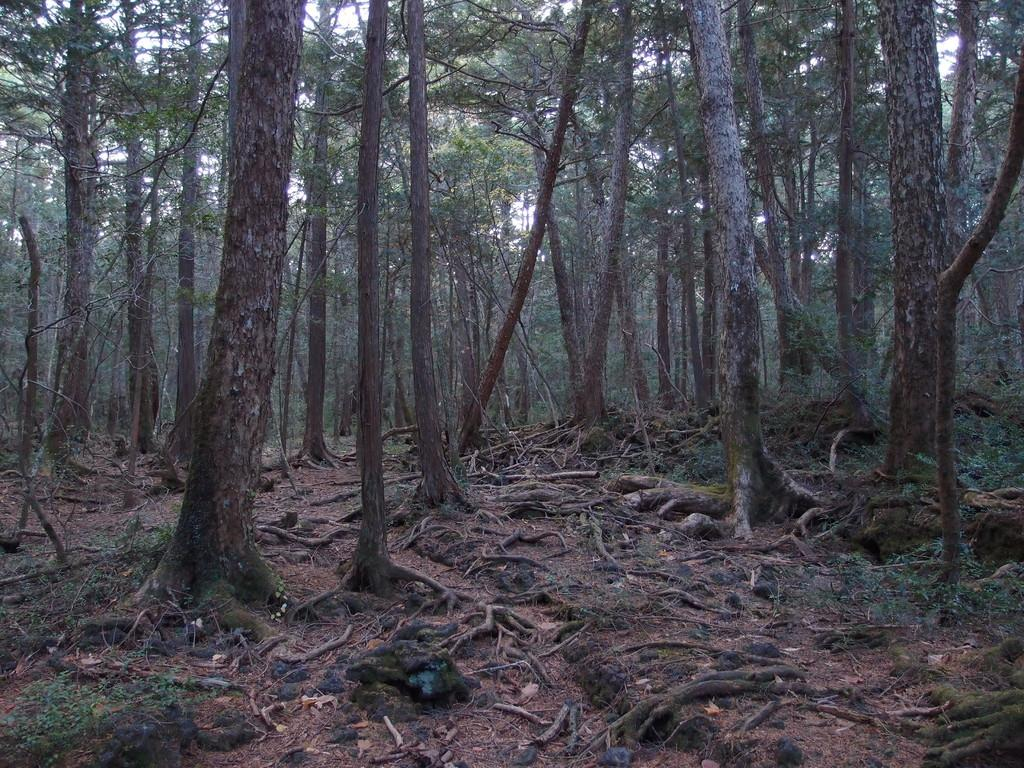What type of vegetation is present in the image? There are trees with branches and leaves in the image. Can you describe any specific features of the trees? The roots of the trees are visible on the ground. What type of environment might the image have been taken in? The image was likely taken in a forest. What type of power tool is being used to cut the trees in the image? There is no power tool or any indication of tree-cutting activity in the image. 